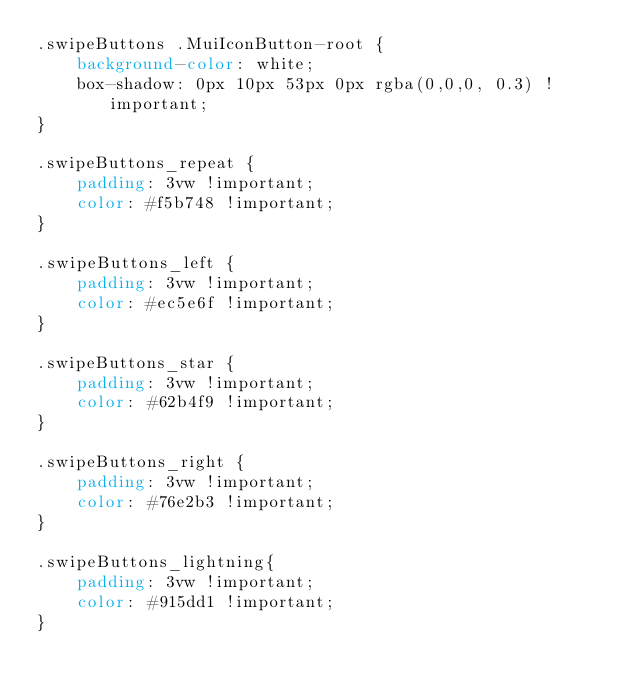<code> <loc_0><loc_0><loc_500><loc_500><_CSS_>.swipeButtons .MuiIconButton-root {
    background-color: white;
    box-shadow: 0px 10px 53px 0px rgba(0,0,0, 0.3) !important;
}

.swipeButtons_repeat {
    padding: 3vw !important;
    color: #f5b748 !important;
}

.swipeButtons_left {
    padding: 3vw !important;
    color: #ec5e6f !important;
}

.swipeButtons_star {
    padding: 3vw !important;
    color: #62b4f9 !important;
}

.swipeButtons_right {
    padding: 3vw !important;
    color: #76e2b3 !important;
}

.swipeButtons_lightning{
    padding: 3vw !important;
    color: #915dd1 !important;
}</code> 